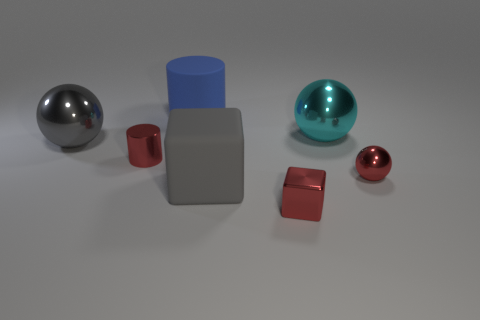Add 2 tiny blue cylinders. How many objects exist? 9 Subtract all big spheres. How many spheres are left? 1 Subtract all blue cylinders. How many cylinders are left? 1 Subtract all cubes. How many objects are left? 5 Add 5 rubber cylinders. How many rubber cylinders are left? 6 Add 7 red metallic cylinders. How many red metallic cylinders exist? 8 Subtract 0 gray cylinders. How many objects are left? 7 Subtract 2 spheres. How many spheres are left? 1 Subtract all brown blocks. Subtract all purple balls. How many blocks are left? 2 Subtract all gray blocks. How many gray balls are left? 1 